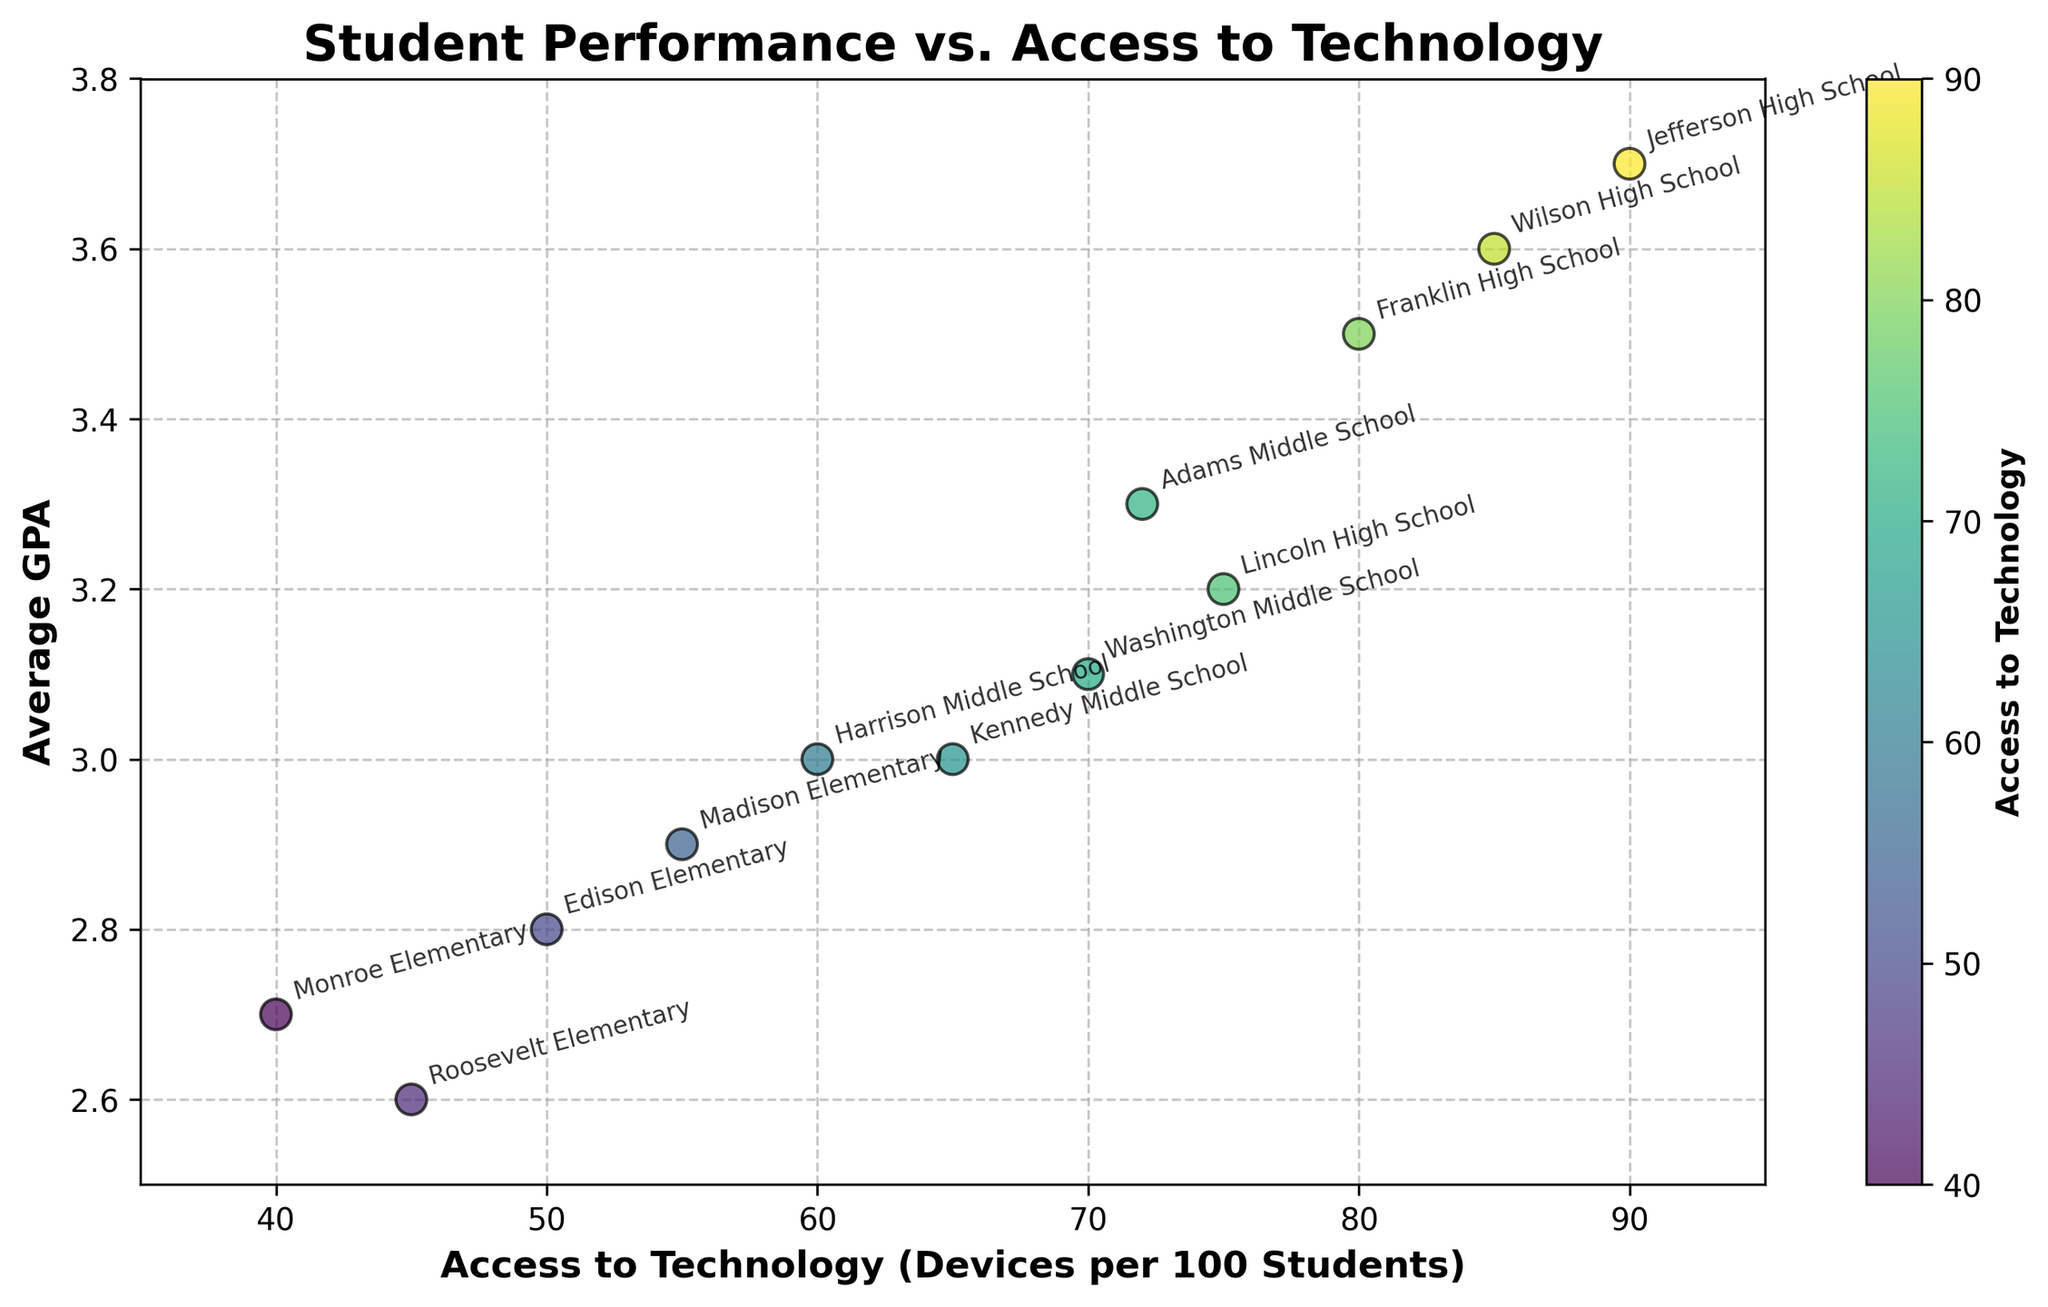How many schools are represented in the plot? There is one data point for each school. Simply count the school names in the annotations or the data points.
Answer: 12 What are the axes labels in the plot? Look at the labels next to the axes to determine what each one represents. The x-axis label is for Access to Technology, and the y-axis label is for Average GPA.
Answer: Access to Technology (Devices per 100 Students), Average GPA Which school has the highest average GPA? Identify the highest point on the y-axis and check the annotation for that data point.
Answer: Jefferson High School What's the range of Access to Technology values in the plot? Look at the minimum and maximum values along the x-axis. The plotted points and axis limits help determine the range.
Answer: 40 to 90 Is there a school with less than 50 devices per 100 students? Check the data points along the x-axis to see if any fall below 50.
Answer: Yes, Roosevelt Elementary and Monroe Elementary Which school has the lowest average GPA and what is that GPA? Identify the lowest point on the y-axis and check the annotation for that data point.
Answer: Roosevelt Elementary, 2.6 What is the general trend between access to technology and average GPA? Observe the overall direction of the data points in the scatter plot. The points generally ascend from left to right, indicating that as access to technology increases, average GPA tends to increase.
Answer: Positive correlation By how much does the average GPA increase when moving from 50 to 70 devices per 100 students, taking the closest schools for reference? Find the schools closest to 50 and 70 devices per 100 students (Edison Elementary and Washington Middle School, respectively), then calculate the difference in their average GPA values (3.1 - 2.8).
Answer: 0.3 Which school has an access to technology value closest to 75 devices per 100 students? Look at the scatter points around the x-axis value of 75 and read the corresponding annotation.
Answer: Lincoln High School What can be inferred about the relationship between access to technology and student performance based on the scatter plot? Analyze the distribution and trend of the points. A positive correlation suggests that increased access to technology is associated with higher student performance (GPA).
Answer: Increased access to technology is associated with higher GPAs 